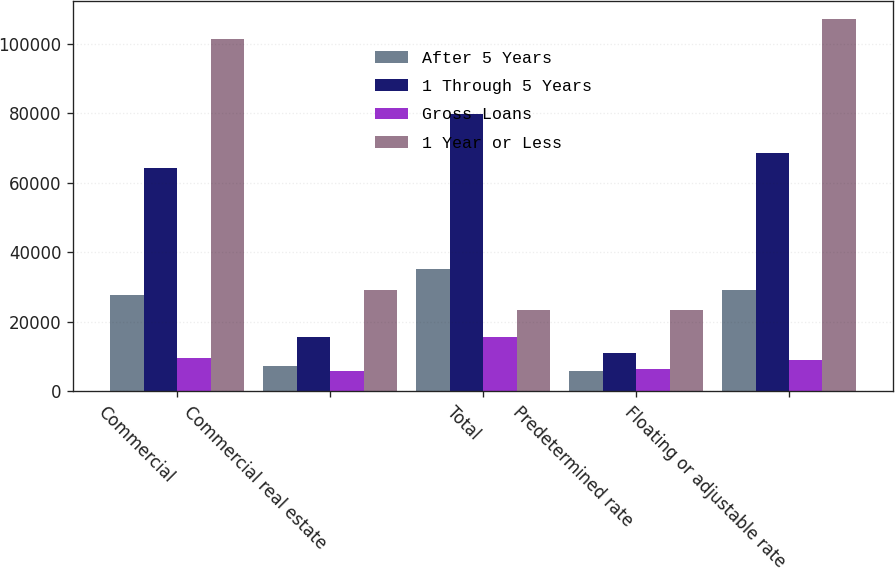Convert chart. <chart><loc_0><loc_0><loc_500><loc_500><stacked_bar_chart><ecel><fcel>Commercial<fcel>Commercial real estate<fcel>Total<fcel>Predetermined rate<fcel>Floating or adjustable rate<nl><fcel>After 5 Years<fcel>27656<fcel>7404<fcel>35060<fcel>5902<fcel>29158<nl><fcel>1 Through 5 Years<fcel>64109<fcel>15658<fcel>79767<fcel>11116<fcel>68651<nl><fcel>Gross Loans<fcel>9599<fcel>5948<fcel>15547<fcel>6392<fcel>9155<nl><fcel>1 Year or Less<fcel>101364<fcel>29010<fcel>23410<fcel>23410<fcel>106964<nl></chart> 